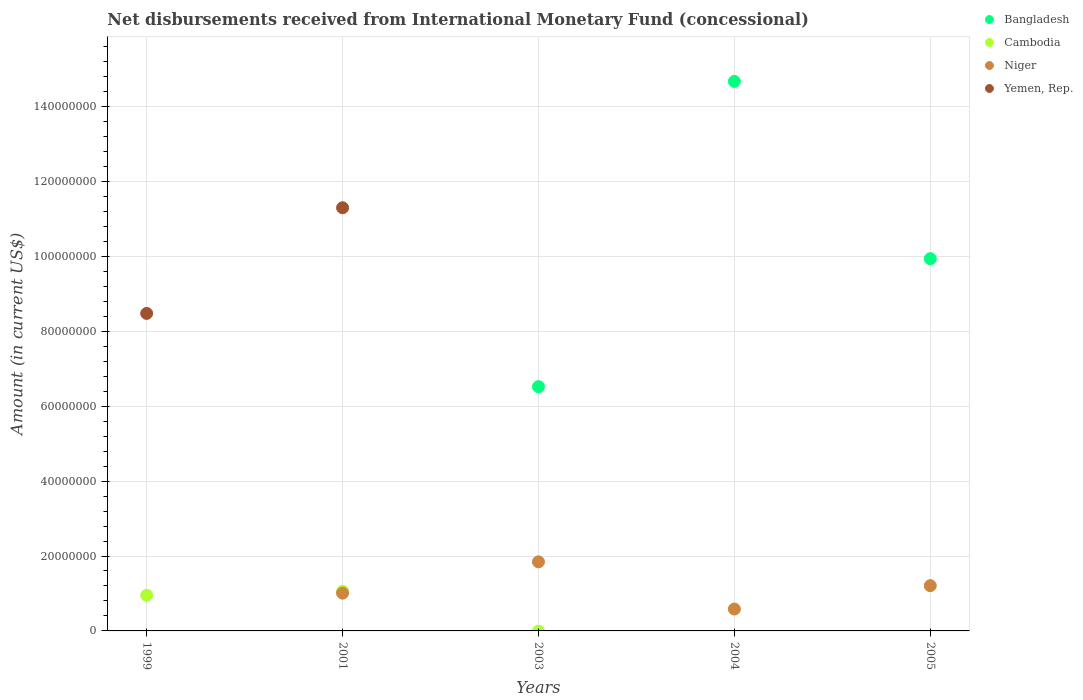Is the number of dotlines equal to the number of legend labels?
Your response must be concise. No. What is the amount of disbursements received from International Monetary Fund in Bangladesh in 2004?
Give a very brief answer. 1.47e+08. Across all years, what is the maximum amount of disbursements received from International Monetary Fund in Bangladesh?
Ensure brevity in your answer.  1.47e+08. In which year was the amount of disbursements received from International Monetary Fund in Bangladesh maximum?
Your answer should be very brief. 2004. What is the total amount of disbursements received from International Monetary Fund in Bangladesh in the graph?
Your answer should be very brief. 3.11e+08. What is the difference between the amount of disbursements received from International Monetary Fund in Niger in 2001 and that in 2005?
Your response must be concise. -1.99e+06. What is the difference between the amount of disbursements received from International Monetary Fund in Cambodia in 1999 and the amount of disbursements received from International Monetary Fund in Niger in 2001?
Make the answer very short. -5.75e+05. What is the average amount of disbursements received from International Monetary Fund in Cambodia per year?
Offer a terse response. 4.02e+06. In the year 2005, what is the difference between the amount of disbursements received from International Monetary Fund in Bangladesh and amount of disbursements received from International Monetary Fund in Niger?
Provide a succinct answer. 8.73e+07. In how many years, is the amount of disbursements received from International Monetary Fund in Niger greater than 80000000 US$?
Your answer should be compact. 0. What is the ratio of the amount of disbursements received from International Monetary Fund in Niger in 2001 to that in 2005?
Offer a terse response. 0.83. Is the difference between the amount of disbursements received from International Monetary Fund in Bangladesh in 2004 and 2005 greater than the difference between the amount of disbursements received from International Monetary Fund in Niger in 2004 and 2005?
Make the answer very short. Yes. What is the difference between the highest and the second highest amount of disbursements received from International Monetary Fund in Niger?
Keep it short and to the point. 6.36e+06. What is the difference between the highest and the lowest amount of disbursements received from International Monetary Fund in Yemen, Rep.?
Offer a very short reply. 1.13e+08. Is the sum of the amount of disbursements received from International Monetary Fund in Bangladesh in 2003 and 2004 greater than the maximum amount of disbursements received from International Monetary Fund in Yemen, Rep. across all years?
Make the answer very short. Yes. Is it the case that in every year, the sum of the amount of disbursements received from International Monetary Fund in Yemen, Rep. and amount of disbursements received from International Monetary Fund in Bangladesh  is greater than the amount of disbursements received from International Monetary Fund in Cambodia?
Your answer should be very brief. Yes. Does the amount of disbursements received from International Monetary Fund in Yemen, Rep. monotonically increase over the years?
Offer a terse response. No. Is the amount of disbursements received from International Monetary Fund in Niger strictly less than the amount of disbursements received from International Monetary Fund in Bangladesh over the years?
Offer a terse response. No. How many dotlines are there?
Provide a short and direct response. 4. What is the difference between two consecutive major ticks on the Y-axis?
Your response must be concise. 2.00e+07. Does the graph contain any zero values?
Give a very brief answer. Yes. How many legend labels are there?
Provide a succinct answer. 4. How are the legend labels stacked?
Give a very brief answer. Vertical. What is the title of the graph?
Provide a succinct answer. Net disbursements received from International Monetary Fund (concessional). What is the Amount (in current US$) in Cambodia in 1999?
Your answer should be compact. 9.51e+06. What is the Amount (in current US$) of Niger in 1999?
Offer a very short reply. 0. What is the Amount (in current US$) of Yemen, Rep. in 1999?
Offer a terse response. 8.48e+07. What is the Amount (in current US$) of Cambodia in 2001?
Offer a very short reply. 1.06e+07. What is the Amount (in current US$) in Niger in 2001?
Your answer should be compact. 1.01e+07. What is the Amount (in current US$) in Yemen, Rep. in 2001?
Offer a terse response. 1.13e+08. What is the Amount (in current US$) in Bangladesh in 2003?
Your answer should be compact. 6.52e+07. What is the Amount (in current US$) of Cambodia in 2003?
Ensure brevity in your answer.  0. What is the Amount (in current US$) of Niger in 2003?
Make the answer very short. 1.84e+07. What is the Amount (in current US$) of Yemen, Rep. in 2003?
Keep it short and to the point. 0. What is the Amount (in current US$) in Bangladesh in 2004?
Keep it short and to the point. 1.47e+08. What is the Amount (in current US$) of Cambodia in 2004?
Provide a short and direct response. 0. What is the Amount (in current US$) of Niger in 2004?
Ensure brevity in your answer.  5.84e+06. What is the Amount (in current US$) of Bangladesh in 2005?
Make the answer very short. 9.94e+07. What is the Amount (in current US$) of Niger in 2005?
Provide a succinct answer. 1.21e+07. Across all years, what is the maximum Amount (in current US$) in Bangladesh?
Offer a terse response. 1.47e+08. Across all years, what is the maximum Amount (in current US$) of Cambodia?
Ensure brevity in your answer.  1.06e+07. Across all years, what is the maximum Amount (in current US$) in Niger?
Make the answer very short. 1.84e+07. Across all years, what is the maximum Amount (in current US$) in Yemen, Rep.?
Provide a succinct answer. 1.13e+08. Across all years, what is the minimum Amount (in current US$) in Bangladesh?
Make the answer very short. 0. Across all years, what is the minimum Amount (in current US$) of Cambodia?
Ensure brevity in your answer.  0. Across all years, what is the minimum Amount (in current US$) in Yemen, Rep.?
Provide a succinct answer. 0. What is the total Amount (in current US$) of Bangladesh in the graph?
Offer a very short reply. 3.11e+08. What is the total Amount (in current US$) of Cambodia in the graph?
Offer a very short reply. 2.01e+07. What is the total Amount (in current US$) in Niger in the graph?
Offer a terse response. 4.65e+07. What is the total Amount (in current US$) in Yemen, Rep. in the graph?
Your response must be concise. 1.98e+08. What is the difference between the Amount (in current US$) of Cambodia in 1999 and that in 2001?
Offer a terse response. -1.07e+06. What is the difference between the Amount (in current US$) of Yemen, Rep. in 1999 and that in 2001?
Provide a succinct answer. -2.82e+07. What is the difference between the Amount (in current US$) of Niger in 2001 and that in 2003?
Your answer should be very brief. -8.36e+06. What is the difference between the Amount (in current US$) in Niger in 2001 and that in 2004?
Your response must be concise. 4.25e+06. What is the difference between the Amount (in current US$) of Niger in 2001 and that in 2005?
Give a very brief answer. -1.99e+06. What is the difference between the Amount (in current US$) in Bangladesh in 2003 and that in 2004?
Provide a succinct answer. -8.15e+07. What is the difference between the Amount (in current US$) of Niger in 2003 and that in 2004?
Keep it short and to the point. 1.26e+07. What is the difference between the Amount (in current US$) in Bangladesh in 2003 and that in 2005?
Provide a short and direct response. -3.42e+07. What is the difference between the Amount (in current US$) of Niger in 2003 and that in 2005?
Your answer should be very brief. 6.36e+06. What is the difference between the Amount (in current US$) in Bangladesh in 2004 and that in 2005?
Your answer should be compact. 4.73e+07. What is the difference between the Amount (in current US$) of Niger in 2004 and that in 2005?
Offer a terse response. -6.24e+06. What is the difference between the Amount (in current US$) in Cambodia in 1999 and the Amount (in current US$) in Niger in 2001?
Provide a short and direct response. -5.75e+05. What is the difference between the Amount (in current US$) of Cambodia in 1999 and the Amount (in current US$) of Yemen, Rep. in 2001?
Offer a very short reply. -1.03e+08. What is the difference between the Amount (in current US$) of Cambodia in 1999 and the Amount (in current US$) of Niger in 2003?
Provide a succinct answer. -8.93e+06. What is the difference between the Amount (in current US$) in Cambodia in 1999 and the Amount (in current US$) in Niger in 2004?
Ensure brevity in your answer.  3.67e+06. What is the difference between the Amount (in current US$) of Cambodia in 1999 and the Amount (in current US$) of Niger in 2005?
Provide a succinct answer. -2.57e+06. What is the difference between the Amount (in current US$) in Cambodia in 2001 and the Amount (in current US$) in Niger in 2003?
Provide a succinct answer. -7.86e+06. What is the difference between the Amount (in current US$) of Cambodia in 2001 and the Amount (in current US$) of Niger in 2004?
Provide a short and direct response. 4.74e+06. What is the difference between the Amount (in current US$) of Cambodia in 2001 and the Amount (in current US$) of Niger in 2005?
Your answer should be very brief. -1.50e+06. What is the difference between the Amount (in current US$) of Bangladesh in 2003 and the Amount (in current US$) of Niger in 2004?
Keep it short and to the point. 5.94e+07. What is the difference between the Amount (in current US$) of Bangladesh in 2003 and the Amount (in current US$) of Niger in 2005?
Ensure brevity in your answer.  5.31e+07. What is the difference between the Amount (in current US$) in Bangladesh in 2004 and the Amount (in current US$) in Niger in 2005?
Make the answer very short. 1.35e+08. What is the average Amount (in current US$) in Bangladesh per year?
Your answer should be compact. 6.23e+07. What is the average Amount (in current US$) in Cambodia per year?
Keep it short and to the point. 4.02e+06. What is the average Amount (in current US$) of Niger per year?
Provide a succinct answer. 9.29e+06. What is the average Amount (in current US$) in Yemen, Rep. per year?
Provide a short and direct response. 3.96e+07. In the year 1999, what is the difference between the Amount (in current US$) of Cambodia and Amount (in current US$) of Yemen, Rep.?
Offer a very short reply. -7.53e+07. In the year 2001, what is the difference between the Amount (in current US$) of Cambodia and Amount (in current US$) of Niger?
Your answer should be compact. 4.96e+05. In the year 2001, what is the difference between the Amount (in current US$) in Cambodia and Amount (in current US$) in Yemen, Rep.?
Offer a terse response. -1.02e+08. In the year 2001, what is the difference between the Amount (in current US$) of Niger and Amount (in current US$) of Yemen, Rep.?
Your answer should be compact. -1.03e+08. In the year 2003, what is the difference between the Amount (in current US$) of Bangladesh and Amount (in current US$) of Niger?
Offer a terse response. 4.68e+07. In the year 2004, what is the difference between the Amount (in current US$) of Bangladesh and Amount (in current US$) of Niger?
Give a very brief answer. 1.41e+08. In the year 2005, what is the difference between the Amount (in current US$) in Bangladesh and Amount (in current US$) in Niger?
Ensure brevity in your answer.  8.73e+07. What is the ratio of the Amount (in current US$) in Cambodia in 1999 to that in 2001?
Ensure brevity in your answer.  0.9. What is the ratio of the Amount (in current US$) of Yemen, Rep. in 1999 to that in 2001?
Ensure brevity in your answer.  0.75. What is the ratio of the Amount (in current US$) of Niger in 2001 to that in 2003?
Your response must be concise. 0.55. What is the ratio of the Amount (in current US$) in Niger in 2001 to that in 2004?
Your response must be concise. 1.73. What is the ratio of the Amount (in current US$) in Niger in 2001 to that in 2005?
Your answer should be compact. 0.83. What is the ratio of the Amount (in current US$) of Bangladesh in 2003 to that in 2004?
Offer a terse response. 0.44. What is the ratio of the Amount (in current US$) of Niger in 2003 to that in 2004?
Your answer should be very brief. 3.16. What is the ratio of the Amount (in current US$) of Bangladesh in 2003 to that in 2005?
Offer a terse response. 0.66. What is the ratio of the Amount (in current US$) of Niger in 2003 to that in 2005?
Offer a terse response. 1.53. What is the ratio of the Amount (in current US$) of Bangladesh in 2004 to that in 2005?
Your answer should be very brief. 1.48. What is the ratio of the Amount (in current US$) of Niger in 2004 to that in 2005?
Offer a very short reply. 0.48. What is the difference between the highest and the second highest Amount (in current US$) of Bangladesh?
Your answer should be very brief. 4.73e+07. What is the difference between the highest and the second highest Amount (in current US$) in Niger?
Offer a very short reply. 6.36e+06. What is the difference between the highest and the lowest Amount (in current US$) of Bangladesh?
Ensure brevity in your answer.  1.47e+08. What is the difference between the highest and the lowest Amount (in current US$) in Cambodia?
Provide a short and direct response. 1.06e+07. What is the difference between the highest and the lowest Amount (in current US$) in Niger?
Provide a succinct answer. 1.84e+07. What is the difference between the highest and the lowest Amount (in current US$) in Yemen, Rep.?
Offer a terse response. 1.13e+08. 